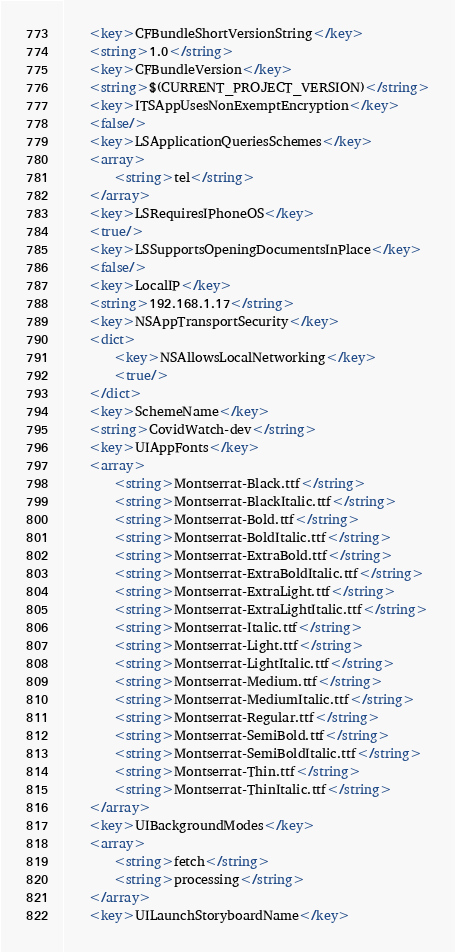<code> <loc_0><loc_0><loc_500><loc_500><_XML_>	<key>CFBundleShortVersionString</key>
	<string>1.0</string>
	<key>CFBundleVersion</key>
	<string>$(CURRENT_PROJECT_VERSION)</string>
	<key>ITSAppUsesNonExemptEncryption</key>
	<false/>
	<key>LSApplicationQueriesSchemes</key>
	<array>
		<string>tel</string>
	</array>
	<key>LSRequiresIPhoneOS</key>
	<true/>
	<key>LSSupportsOpeningDocumentsInPlace</key>
	<false/>
	<key>LocalIP</key>
	<string>192.168.1.17</string>
	<key>NSAppTransportSecurity</key>
	<dict>
		<key>NSAllowsLocalNetworking</key>
		<true/>
	</dict>
	<key>SchemeName</key>
	<string>CovidWatch-dev</string>
	<key>UIAppFonts</key>
	<array>
		<string>Montserrat-Black.ttf</string>
		<string>Montserrat-BlackItalic.ttf</string>
		<string>Montserrat-Bold.ttf</string>
		<string>Montserrat-BoldItalic.ttf</string>
		<string>Montserrat-ExtraBold.ttf</string>
		<string>Montserrat-ExtraBoldItalic.ttf</string>
		<string>Montserrat-ExtraLight.ttf</string>
		<string>Montserrat-ExtraLightItalic.ttf</string>
		<string>Montserrat-Italic.ttf</string>
		<string>Montserrat-Light.ttf</string>
		<string>Montserrat-LightItalic.ttf</string>
		<string>Montserrat-Medium.ttf</string>
		<string>Montserrat-MediumItalic.ttf</string>
		<string>Montserrat-Regular.ttf</string>
		<string>Montserrat-SemiBold.ttf</string>
		<string>Montserrat-SemiBoldItalic.ttf</string>
		<string>Montserrat-Thin.ttf</string>
		<string>Montserrat-ThinItalic.ttf</string>
	</array>
	<key>UIBackgroundModes</key>
	<array>
		<string>fetch</string>
		<string>processing</string>
	</array>
	<key>UILaunchStoryboardName</key></code> 